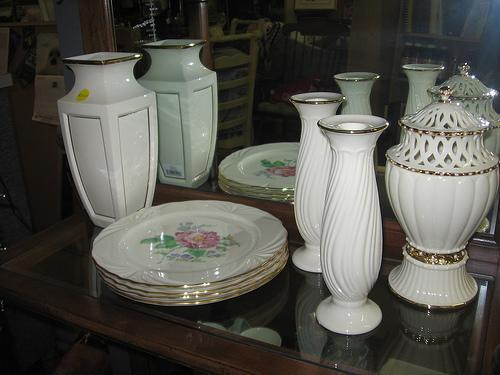How many vases are in this picture?
Give a very brief answer. 3. How many vases are there?
Give a very brief answer. 3. How many identical vases are there?
Give a very brief answer. 2. How many dinner plates are there?
Give a very brief answer. 4. 